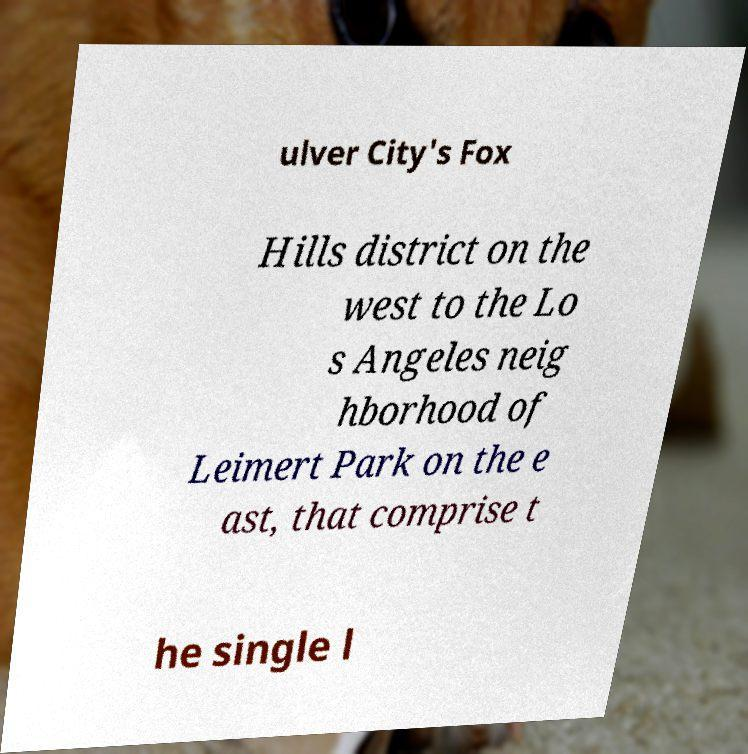For documentation purposes, I need the text within this image transcribed. Could you provide that? ulver City's Fox Hills district on the west to the Lo s Angeles neig hborhood of Leimert Park on the e ast, that comprise t he single l 